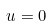<formula> <loc_0><loc_0><loc_500><loc_500>u = 0</formula> 